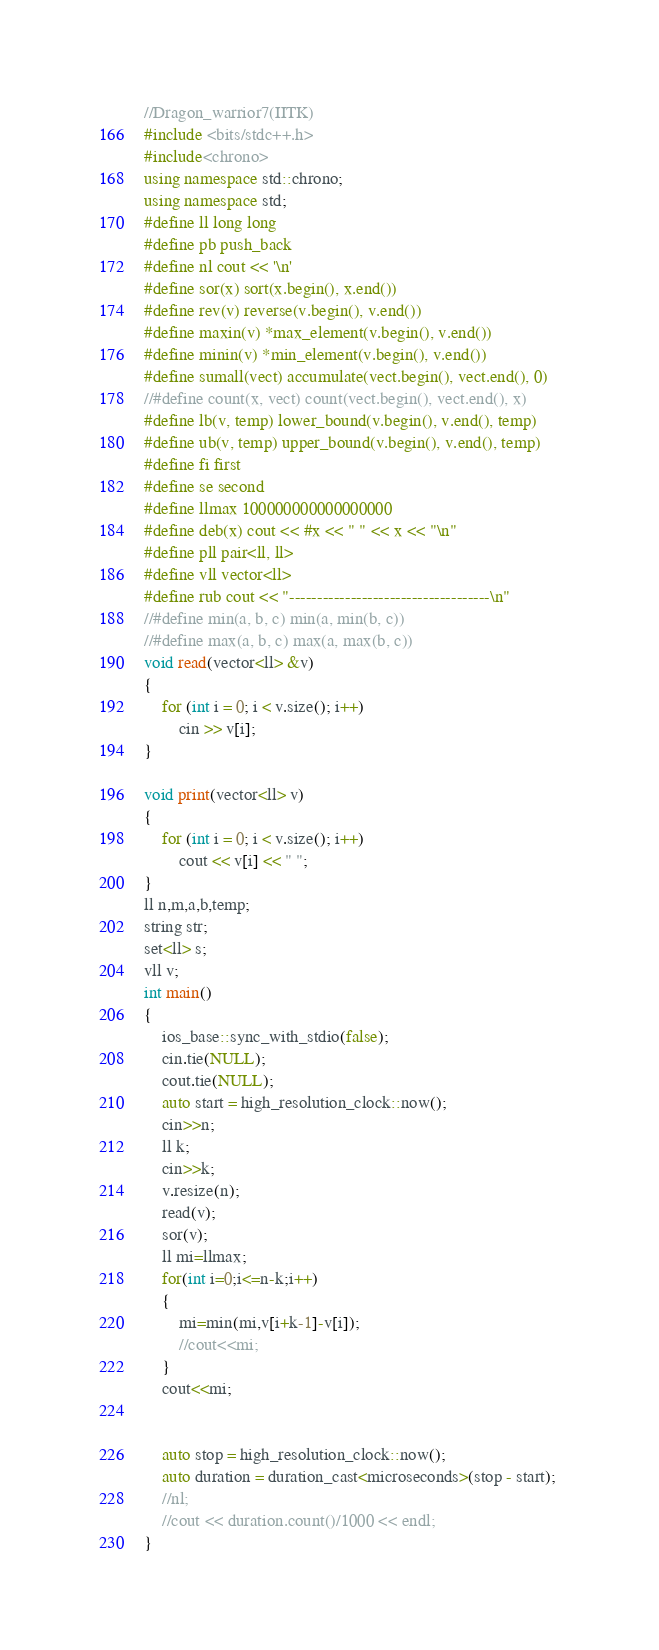<code> <loc_0><loc_0><loc_500><loc_500><_C++_>//Dragon_warrior7(IITK)
#include <bits/stdc++.h>
#include<chrono>
using namespace std::chrono; 
using namespace std;
#define ll long long
#define pb push_back
#define nl cout << '\n'
#define sor(x) sort(x.begin(), x.end())
#define rev(v) reverse(v.begin(), v.end())
#define maxin(v) *max_element(v.begin(), v.end())
#define minin(v) *min_element(v.begin(), v.end())
#define sumall(vect) accumulate(vect.begin(), vect.end(), 0)
//#define count(x, vect) count(vect.begin(), vect.end(), x)
#define lb(v, temp) lower_bound(v.begin(), v.end(), temp)
#define ub(v, temp) upper_bound(v.begin(), v.end(), temp)
#define fi first
#define se second
#define llmax 100000000000000000
#define deb(x) cout << #x << " " << x << "\n"
#define pll pair<ll, ll> 
#define vll vector<ll> 
#define rub cout << "------------------------------------\n"
//#define min(a, b, c) min(a, min(b, c))
//#define max(a, b, c) max(a, max(b, c))
void read(vector<ll> &v)
{
	for (int i = 0; i < v.size(); i++)
		cin >> v[i];
}

void print(vector<ll> v)
{
	for (int i = 0; i < v.size(); i++)
		cout << v[i] << " ";
}
ll n,m,a,b,temp;
string str;
set<ll> s;
vll v;
int main()
{
	ios_base::sync_with_stdio(false);
	cin.tie(NULL);
	cout.tie(NULL);
	auto start = high_resolution_clock::now(); 
	cin>>n;
	ll k;
	cin>>k;
	v.resize(n);
	read(v);
	sor(v);
	ll mi=llmax;
	for(int i=0;i<=n-k;i++)
	{
		mi=min(mi,v[i+k-1]-v[i]);
		//cout<<mi;
	}
	cout<<mi;
	
	
	auto stop = high_resolution_clock::now();
	auto duration = duration_cast<microseconds>(stop - start); 
	//nl;
	//cout << duration.count()/1000 << endl; 
}</code> 